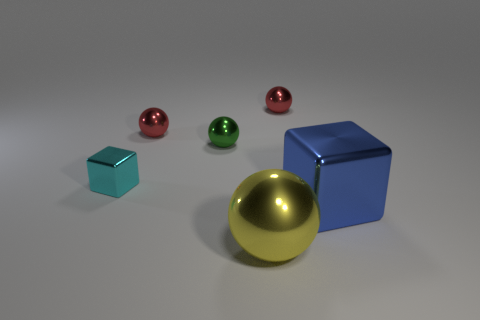Subtract all small spheres. How many spheres are left? 1 Subtract all green spheres. How many spheres are left? 3 Add 4 big cyan balls. How many objects exist? 10 Subtract 0 gray balls. How many objects are left? 6 Subtract all spheres. How many objects are left? 2 Subtract 2 blocks. How many blocks are left? 0 Subtract all brown spheres. Subtract all blue cubes. How many spheres are left? 4 Subtract all cyan cubes. How many green spheres are left? 1 Subtract all big green shiny spheres. Subtract all small red things. How many objects are left? 4 Add 1 blocks. How many blocks are left? 3 